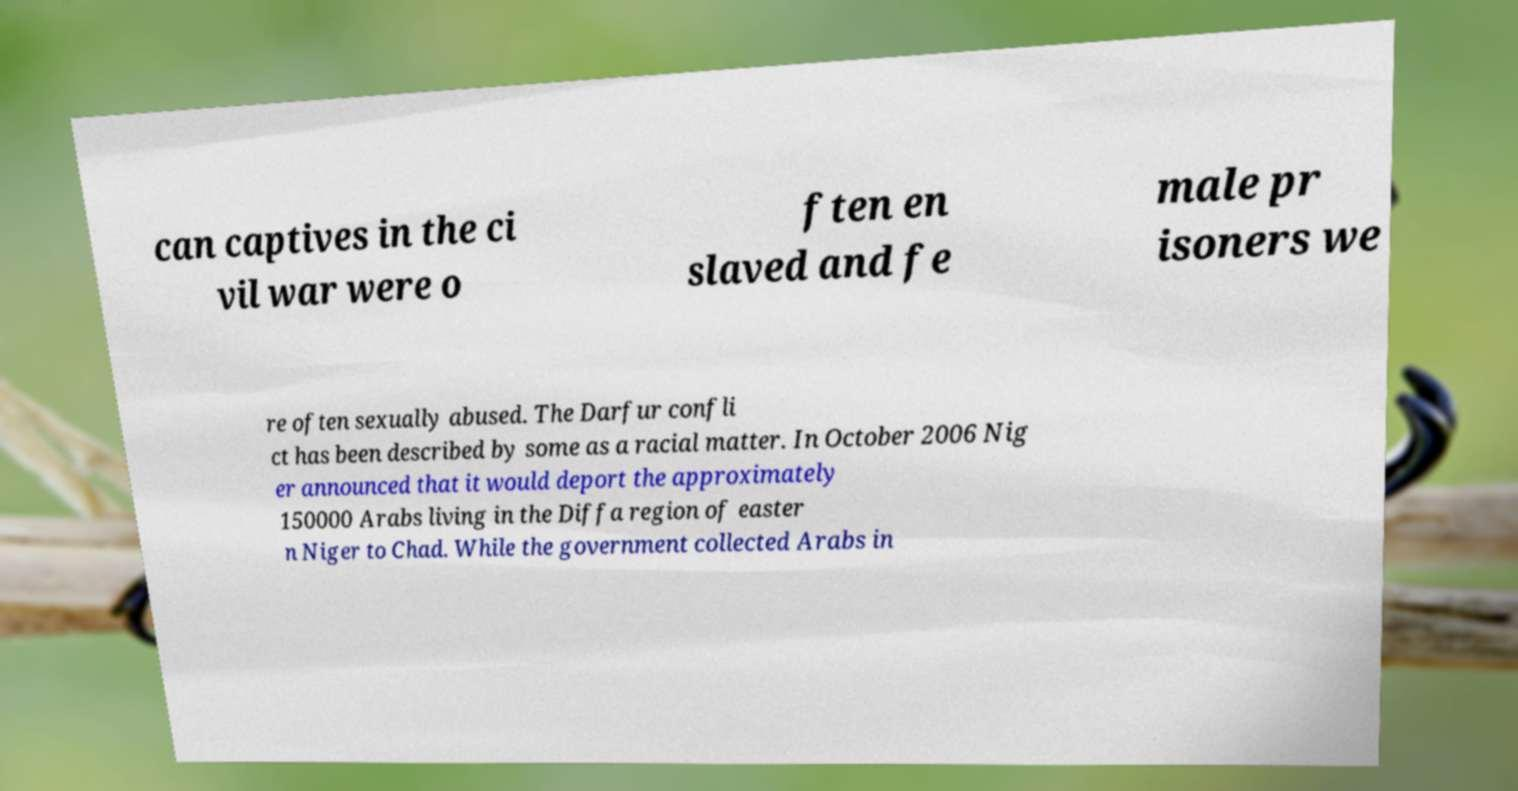I need the written content from this picture converted into text. Can you do that? can captives in the ci vil war were o ften en slaved and fe male pr isoners we re often sexually abused. The Darfur confli ct has been described by some as a racial matter. In October 2006 Nig er announced that it would deport the approximately 150000 Arabs living in the Diffa region of easter n Niger to Chad. While the government collected Arabs in 